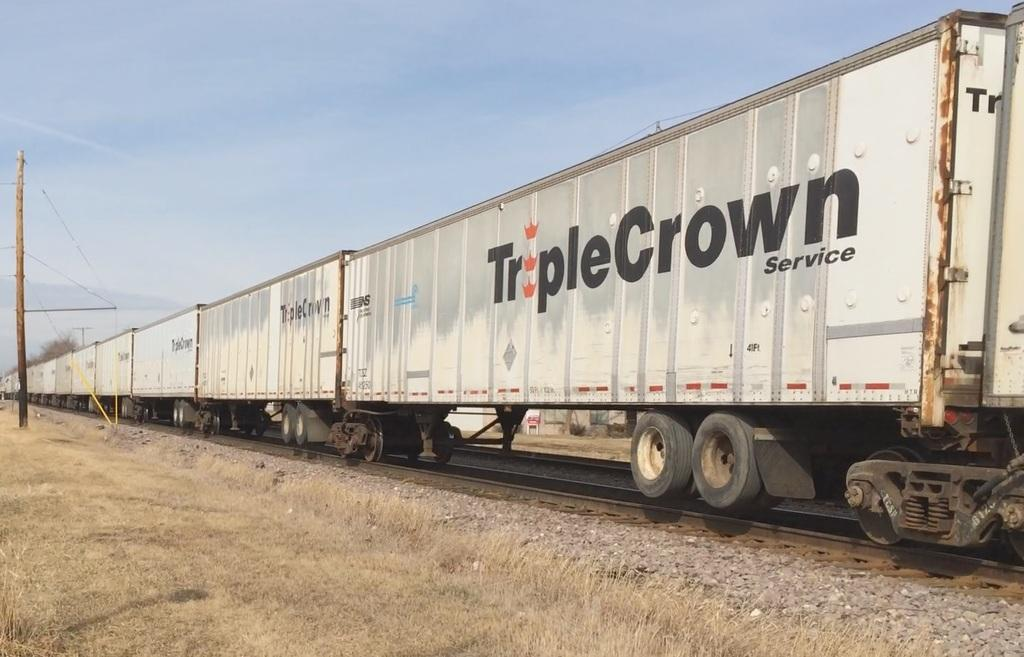<image>
Summarize the visual content of the image. A row of TripleCrown Service train cars are on a train track. 